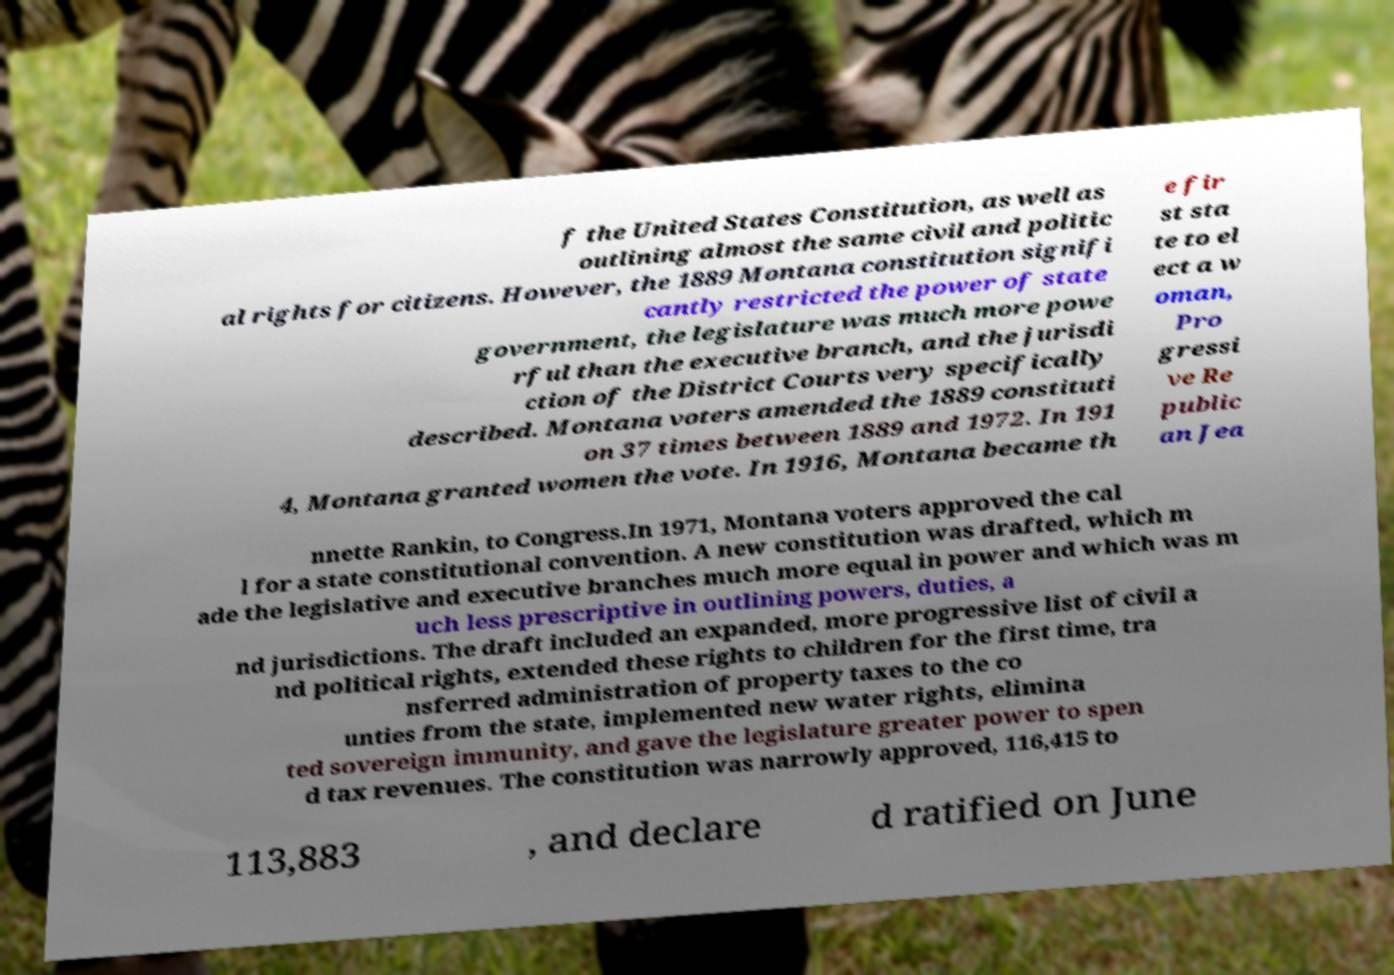Could you assist in decoding the text presented in this image and type it out clearly? f the United States Constitution, as well as outlining almost the same civil and politic al rights for citizens. However, the 1889 Montana constitution signifi cantly restricted the power of state government, the legislature was much more powe rful than the executive branch, and the jurisdi ction of the District Courts very specifically described. Montana voters amended the 1889 constituti on 37 times between 1889 and 1972. In 191 4, Montana granted women the vote. In 1916, Montana became th e fir st sta te to el ect a w oman, Pro gressi ve Re public an Jea nnette Rankin, to Congress.In 1971, Montana voters approved the cal l for a state constitutional convention. A new constitution was drafted, which m ade the legislative and executive branches much more equal in power and which was m uch less prescriptive in outlining powers, duties, a nd jurisdictions. The draft included an expanded, more progressive list of civil a nd political rights, extended these rights to children for the first time, tra nsferred administration of property taxes to the co unties from the state, implemented new water rights, elimina ted sovereign immunity, and gave the legislature greater power to spen d tax revenues. The constitution was narrowly approved, 116,415 to 113,883 , and declare d ratified on June 